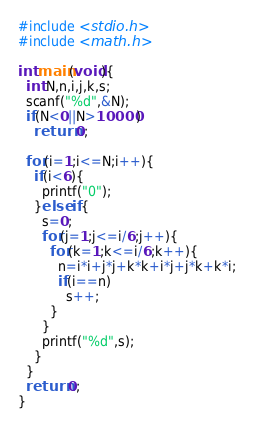<code> <loc_0><loc_0><loc_500><loc_500><_C_>#include <stdio.h>
#include <math.h>

int main(void){
  int N,n,i,j,k,s;
  scanf("%d",&N);
  if(N<0||N>10000)
    return 0;
  
  for(i=1;i<=N;i++){
    if(i<6){
      printf("0");
    }else if{
      s=0;
      for(j=1;j<=i/6;j++){
        for(k=1;k<=i/6;k++){
          n=i*i+j*j+k*k+i*j+j*k+k*i;
          if(i==n)
            s++;
        }
      }
      printf("%d",s);
    }
  }
  return 0;
}
</code> 